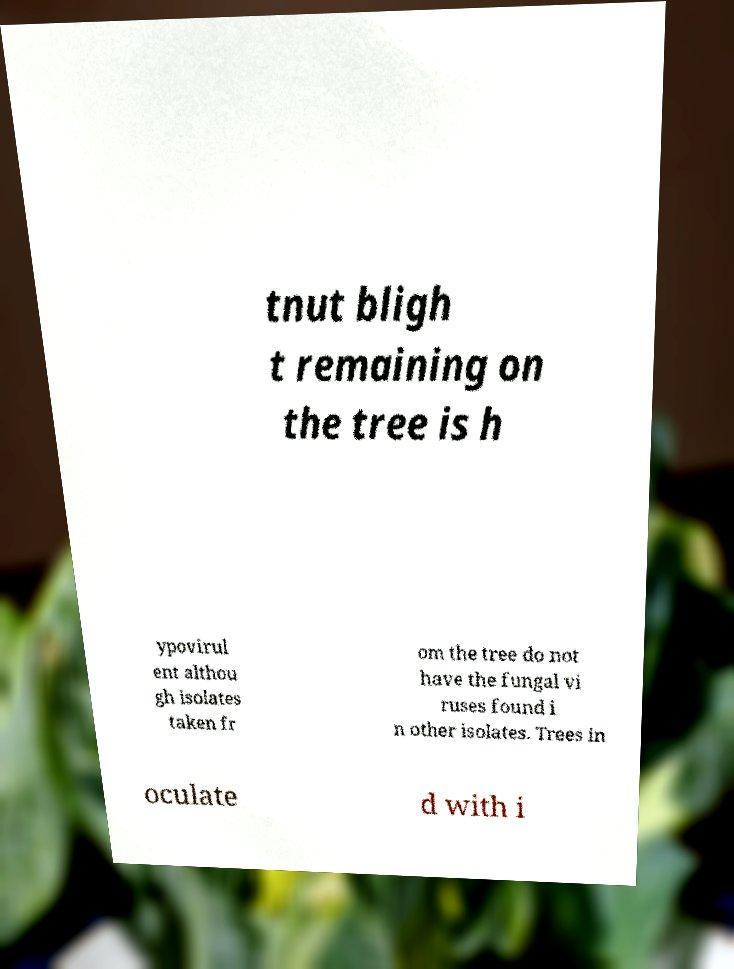There's text embedded in this image that I need extracted. Can you transcribe it verbatim? tnut bligh t remaining on the tree is h ypovirul ent althou gh isolates taken fr om the tree do not have the fungal vi ruses found i n other isolates. Trees in oculate d with i 